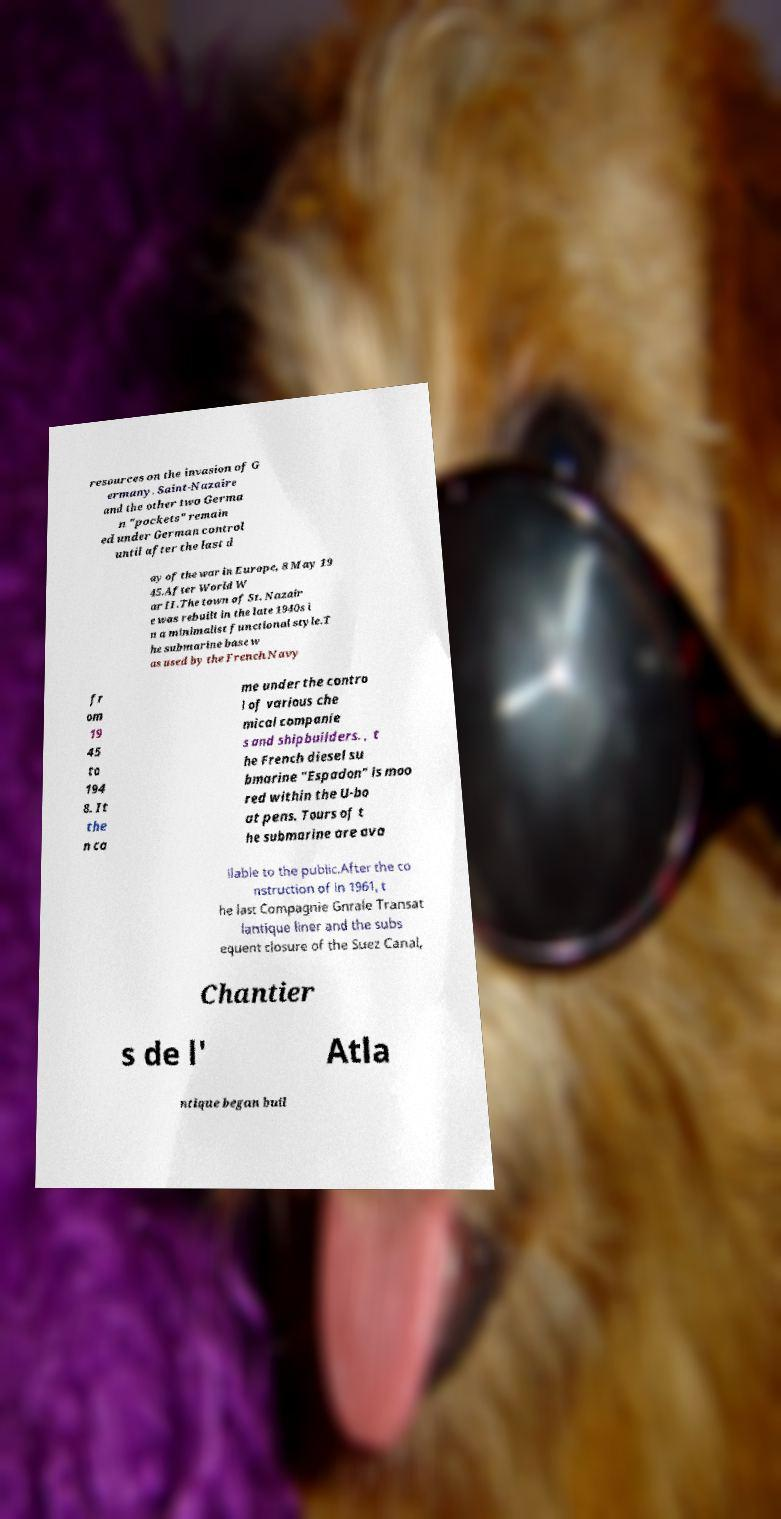There's text embedded in this image that I need extracted. Can you transcribe it verbatim? resources on the invasion of G ermany. Saint-Nazaire and the other two Germa n "pockets" remain ed under German control until after the last d ay of the war in Europe, 8 May 19 45.After World W ar II.The town of St. Nazair e was rebuilt in the late 1940s i n a minimalist functional style.T he submarine base w as used by the French Navy fr om 19 45 to 194 8. It the n ca me under the contro l of various che mical companie s and shipbuilders. , t he French diesel su bmarine "Espadon" is moo red within the U-bo at pens. Tours of t he submarine are ava ilable to the public.After the co nstruction of in 1961, t he last Compagnie Gnrale Transat lantique liner and the subs equent closure of the Suez Canal, Chantier s de l' Atla ntique began buil 